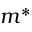Convert formula to latex. <formula><loc_0><loc_0><loc_500><loc_500>m ^ { * }</formula> 